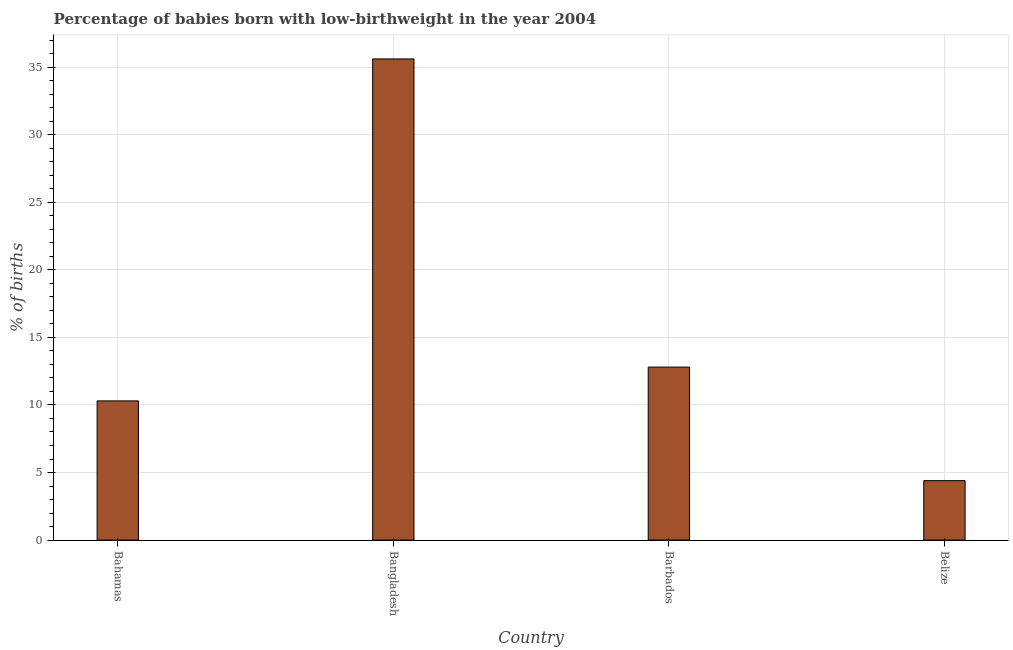Does the graph contain grids?
Your answer should be very brief. Yes. What is the title of the graph?
Offer a very short reply. Percentage of babies born with low-birthweight in the year 2004. What is the label or title of the Y-axis?
Your answer should be very brief. % of births. What is the percentage of babies who were born with low-birthweight in Bangladesh?
Give a very brief answer. 35.6. Across all countries, what is the maximum percentage of babies who were born with low-birthweight?
Your response must be concise. 35.6. Across all countries, what is the minimum percentage of babies who were born with low-birthweight?
Keep it short and to the point. 4.4. In which country was the percentage of babies who were born with low-birthweight maximum?
Give a very brief answer. Bangladesh. In which country was the percentage of babies who were born with low-birthweight minimum?
Offer a terse response. Belize. What is the sum of the percentage of babies who were born with low-birthweight?
Your answer should be compact. 63.1. What is the difference between the percentage of babies who were born with low-birthweight in Barbados and Belize?
Provide a short and direct response. 8.4. What is the average percentage of babies who were born with low-birthweight per country?
Provide a short and direct response. 15.78. What is the median percentage of babies who were born with low-birthweight?
Keep it short and to the point. 11.55. In how many countries, is the percentage of babies who were born with low-birthweight greater than 18 %?
Provide a short and direct response. 1. What is the ratio of the percentage of babies who were born with low-birthweight in Bahamas to that in Belize?
Give a very brief answer. 2.34. Is the percentage of babies who were born with low-birthweight in Bahamas less than that in Bangladesh?
Provide a short and direct response. Yes. Is the difference between the percentage of babies who were born with low-birthweight in Bahamas and Bangladesh greater than the difference between any two countries?
Ensure brevity in your answer.  No. What is the difference between the highest and the second highest percentage of babies who were born with low-birthweight?
Provide a succinct answer. 22.8. Is the sum of the percentage of babies who were born with low-birthweight in Bahamas and Belize greater than the maximum percentage of babies who were born with low-birthweight across all countries?
Your answer should be very brief. No. What is the difference between the highest and the lowest percentage of babies who were born with low-birthweight?
Provide a short and direct response. 31.2. In how many countries, is the percentage of babies who were born with low-birthweight greater than the average percentage of babies who were born with low-birthweight taken over all countries?
Offer a terse response. 1. Are all the bars in the graph horizontal?
Make the answer very short. No. How many countries are there in the graph?
Your answer should be compact. 4. What is the % of births in Bahamas?
Provide a succinct answer. 10.3. What is the % of births of Bangladesh?
Give a very brief answer. 35.6. What is the % of births of Barbados?
Offer a very short reply. 12.8. What is the difference between the % of births in Bahamas and Bangladesh?
Ensure brevity in your answer.  -25.3. What is the difference between the % of births in Bangladesh and Barbados?
Provide a succinct answer. 22.8. What is the difference between the % of births in Bangladesh and Belize?
Give a very brief answer. 31.2. What is the difference between the % of births in Barbados and Belize?
Provide a short and direct response. 8.4. What is the ratio of the % of births in Bahamas to that in Bangladesh?
Make the answer very short. 0.29. What is the ratio of the % of births in Bahamas to that in Barbados?
Offer a very short reply. 0.81. What is the ratio of the % of births in Bahamas to that in Belize?
Make the answer very short. 2.34. What is the ratio of the % of births in Bangladesh to that in Barbados?
Keep it short and to the point. 2.78. What is the ratio of the % of births in Bangladesh to that in Belize?
Ensure brevity in your answer.  8.09. What is the ratio of the % of births in Barbados to that in Belize?
Keep it short and to the point. 2.91. 